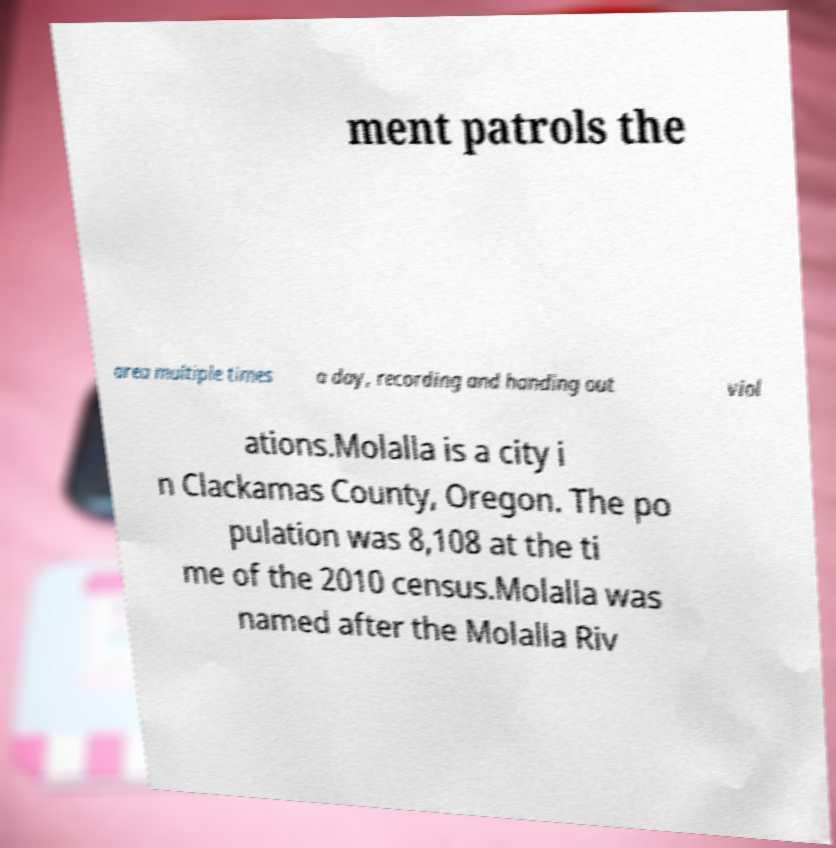There's text embedded in this image that I need extracted. Can you transcribe it verbatim? ment patrols the area multiple times a day, recording and handing out viol ations.Molalla is a city i n Clackamas County, Oregon. The po pulation was 8,108 at the ti me of the 2010 census.Molalla was named after the Molalla Riv 